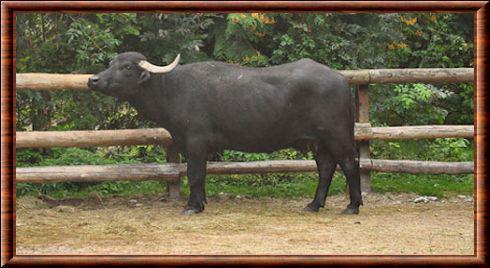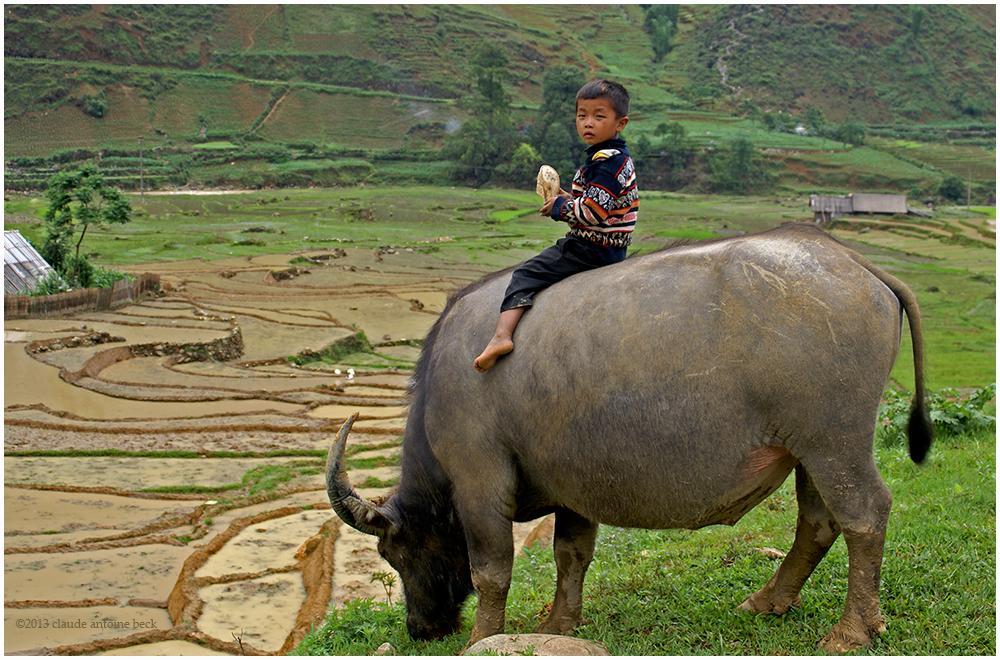The first image is the image on the left, the second image is the image on the right. For the images shown, is this caption "Exactly one image shows a water buffalo standing in water, and there is only one animal in the image." true? Answer yes or no. No. The first image is the image on the left, the second image is the image on the right. Examine the images to the left and right. Is the description "At least one cow is standing chest deep in water." accurate? Answer yes or no. No. 